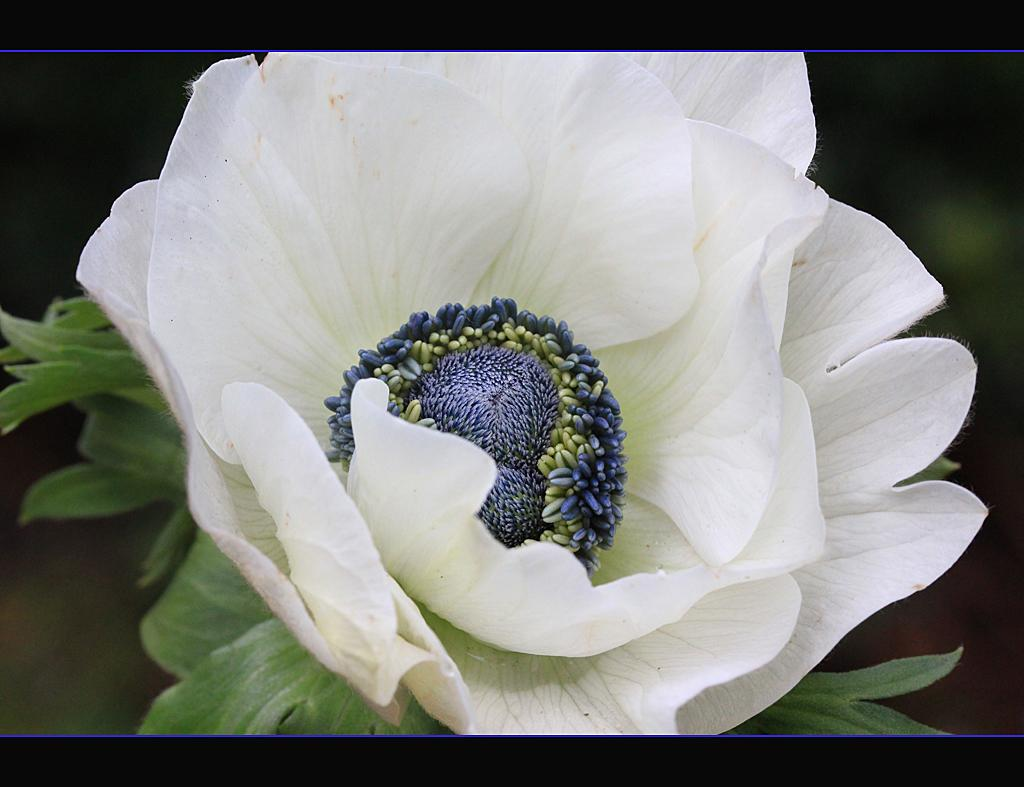What is the main subject of the image? There is a flower in the center of the image. Can you describe the background of the image? The background of the image is blurred. What type of pain is the flower experiencing in the image? There is no indication in the image that the flower is experiencing any pain. Can you point out the spot on the flower that is most vibrant in the image? There is no specific spot mentioned on the flower; it is a single subject in the image. 